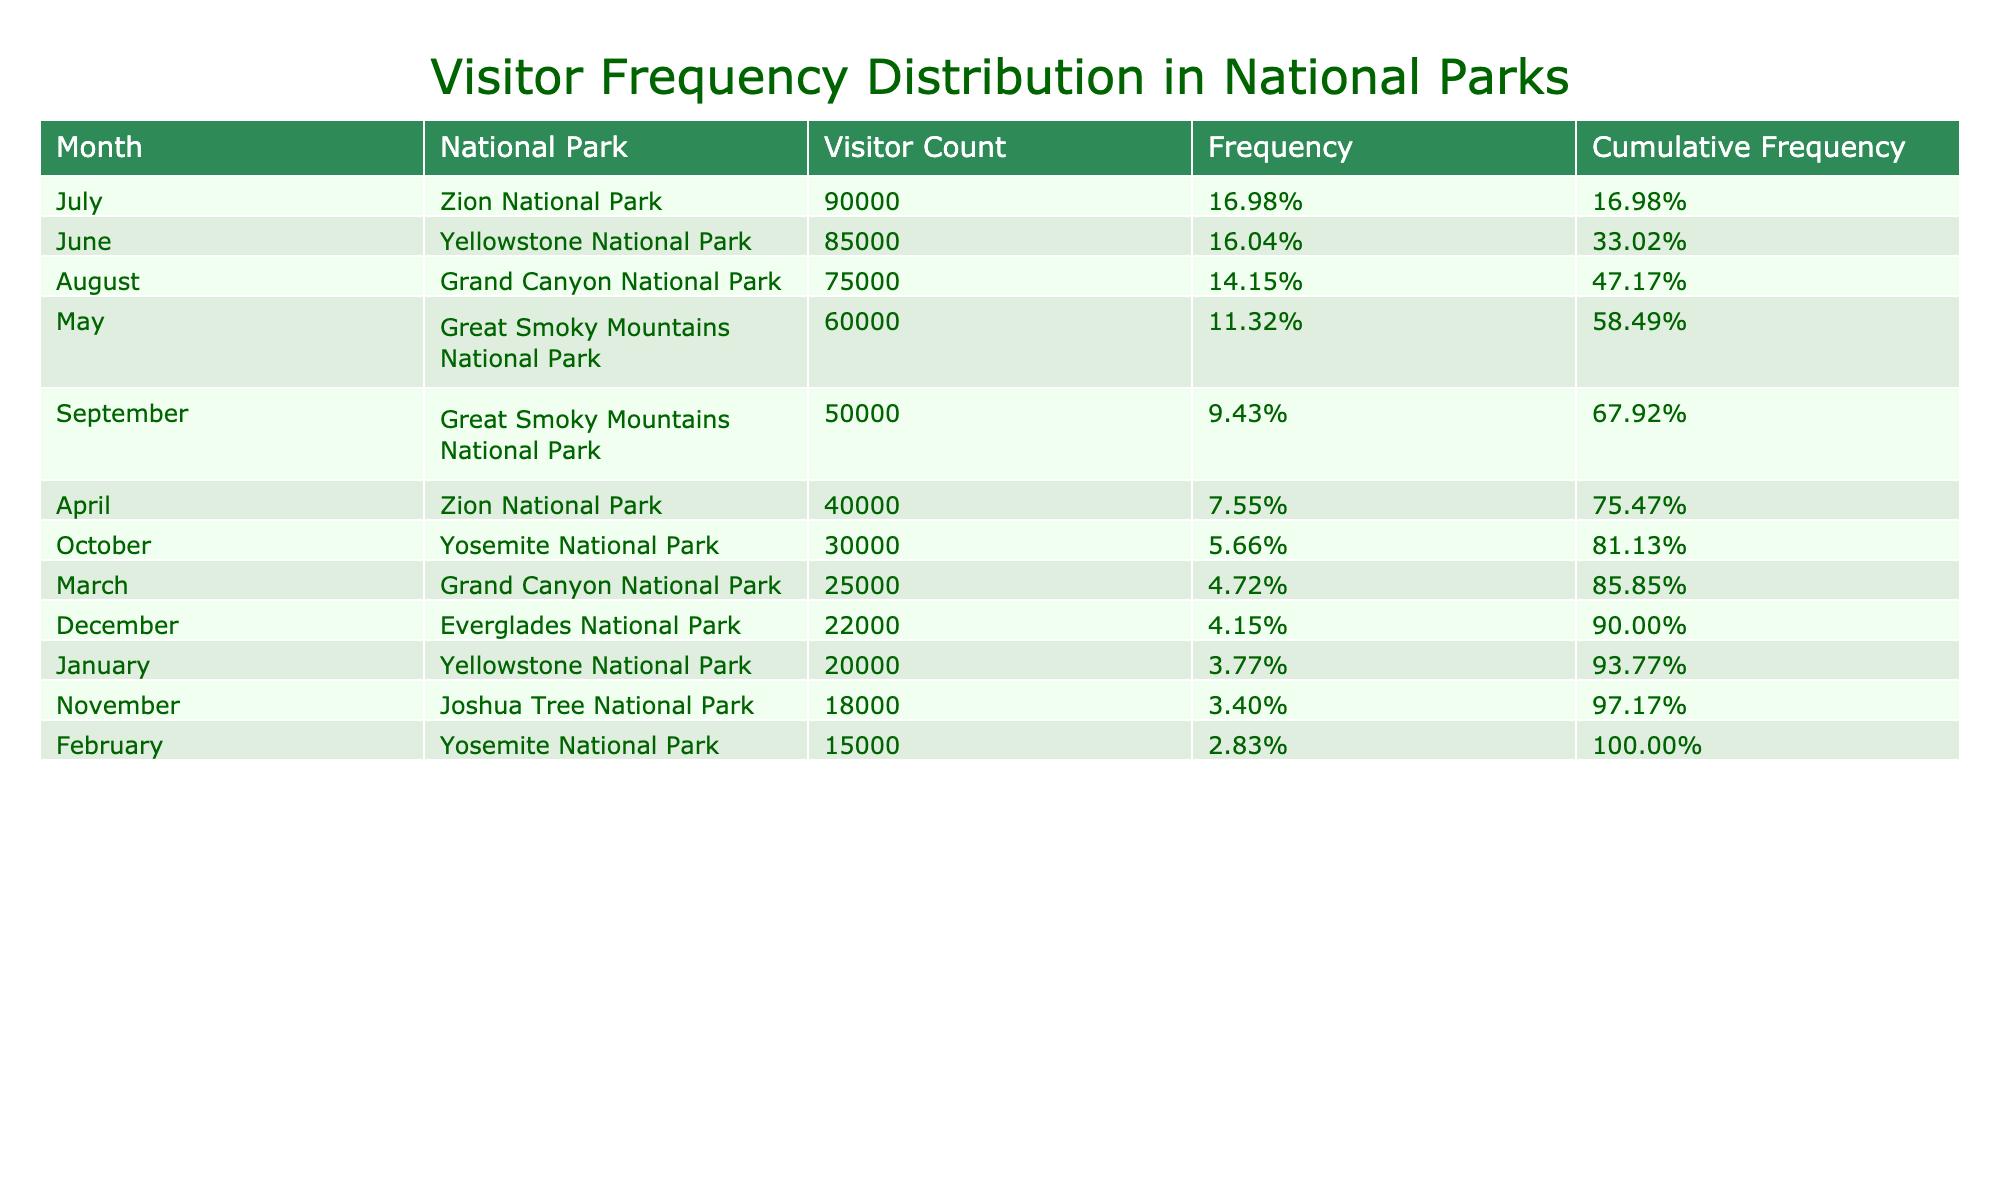What is the month with the highest visitor count? By scanning the table, I notice that July has the highest visitor count at 90,000.
Answer: July Which national park had the second highest visitor count? By examining the table, I can see that Zion National Park has the second highest visitor count, which is 85,000 in July.
Answer: Zion National Park How many visitors did the Great Smoky Mountains National Park have in September? The table shows that the Great Smoky Mountains National Park had 50,000 visitors in September.
Answer: 50,000 What is the total visitor count for the months of May and June? May had 60,000 visitors and June had 85,000 visitors. Summing these gives 60,000 + 85,000 = 145,000.
Answer: 145,000 Is the visitor count in October greater than that in December? According to the table, October has 30,000 visitors while December has 22,000 visitors. Since 30,000 is greater than 22,000, the answer is yes.
Answer: Yes Which month had a visitor count of 20,000? The table indicates that January had a visitor count of 20,000.
Answer: January What is the average visitor count across all months? To find the average, I first calculate the total visitor count by adding all values and then divide by the number of months (12). The total visitor count is 520,000 and average is 520,000 / 12 ≈ 43,333.
Answer: 43,333 Did Yosemite National Park have more visitors in October than in February? Yosemite National Park had 30,000 visitors in October and 15,000 in February. Since 30,000 is more than 15,000, the answer is yes.
Answer: Yes Which month has the lowest visitor count, and what is that count? Scanning the table, November has the lowest visitor count of 18,000.
Answer: November, 18,000 